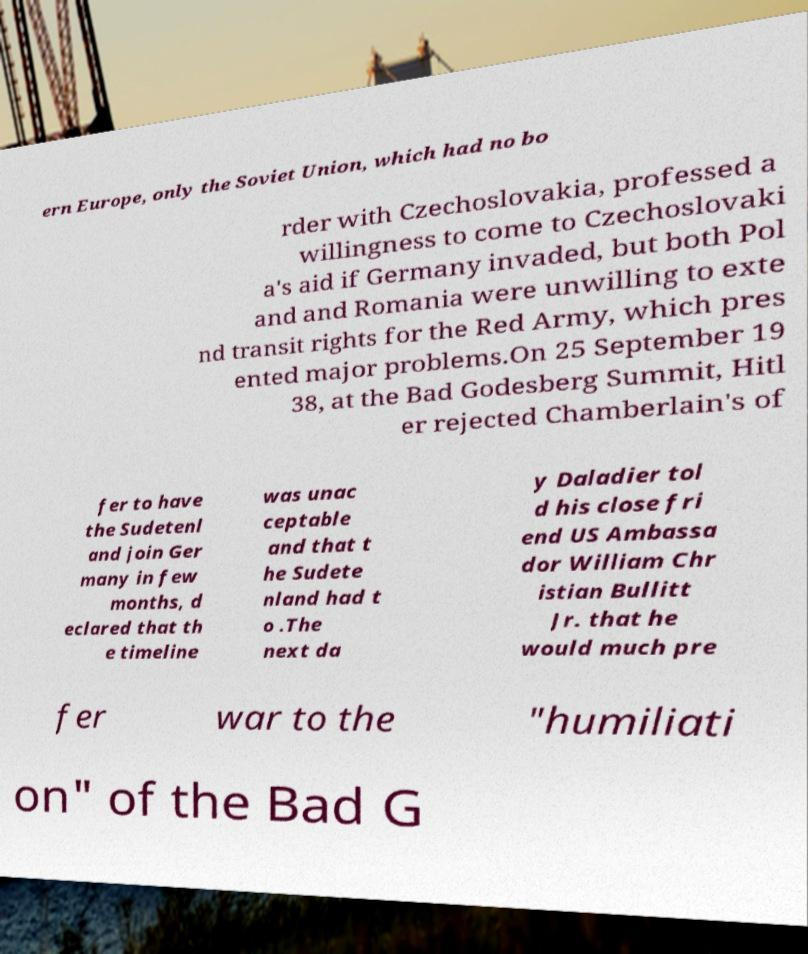I need the written content from this picture converted into text. Can you do that? ern Europe, only the Soviet Union, which had no bo rder with Czechoslovakia, professed a willingness to come to Czechoslovaki a's aid if Germany invaded, but both Pol and and Romania were unwilling to exte nd transit rights for the Red Army, which pres ented major problems.On 25 September 19 38, at the Bad Godesberg Summit, Hitl er rejected Chamberlain's of fer to have the Sudetenl and join Ger many in few months, d eclared that th e timeline was unac ceptable and that t he Sudete nland had t o .The next da y Daladier tol d his close fri end US Ambassa dor William Chr istian Bullitt Jr. that he would much pre fer war to the "humiliati on" of the Bad G 